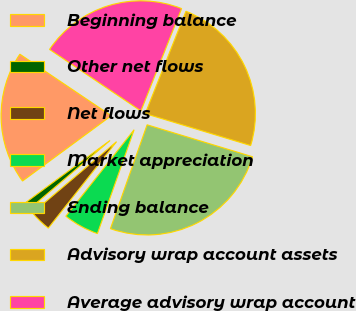<chart> <loc_0><loc_0><loc_500><loc_500><pie_chart><fcel>Beginning balance<fcel>Other net flows<fcel>Net flows<fcel>Market appreciation<fcel>Ending balance<fcel>Advisory wrap account assets<fcel>Average advisory wrap account<nl><fcel>19.53%<fcel>1.1%<fcel>3.17%<fcel>5.23%<fcel>25.72%<fcel>23.66%<fcel>21.59%<nl></chart> 